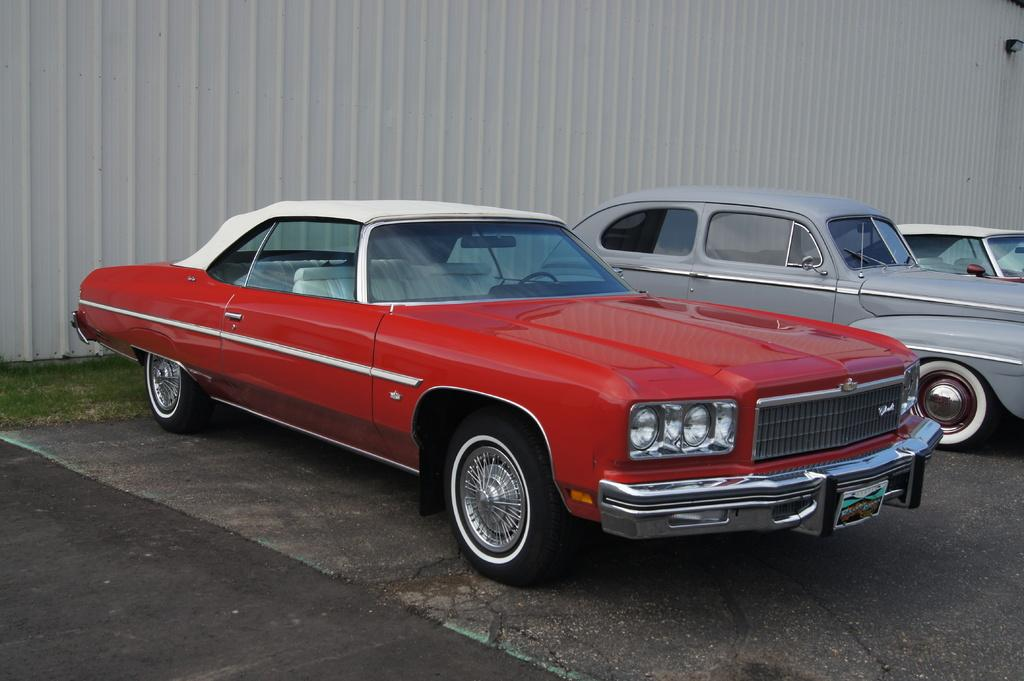What can be found in the parking space in the image? There are vehicles in the parking space in the image. What type of vegetation is visible in the image? Green grass is visible in the image. What structures can be seen in the background of the image? There is a roof, sheet, and wall in the background of the image. What type of cake is being served at the picnic in the image? There is no picnic or cake present in the image; it features vehicles in a parking space and green grass. Can you see a robin perched on the roof in the image? There is no robin present in the image; it only shows vehicles, green grass, and structures in the background. 